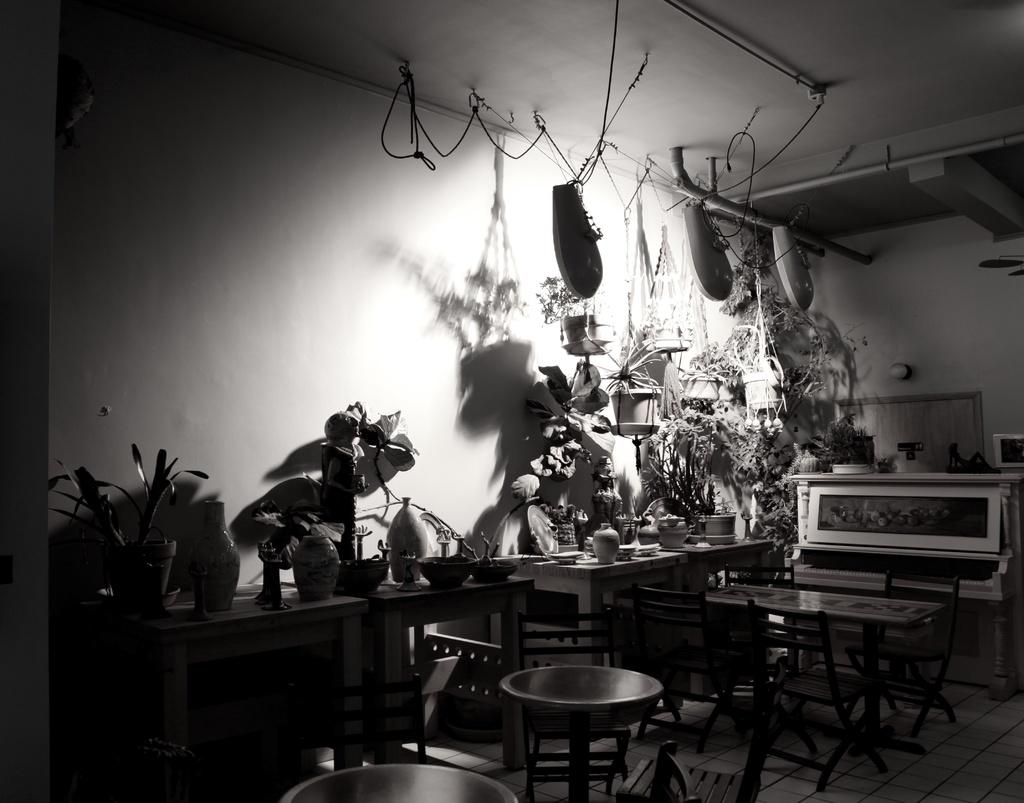What is the color scheme of the image? The image is black and white. What celestial bodies are depicted in the image? There are planets depicted in the image. What type of furniture is present in the image? There are tables and chairs in the image. What type of dishware is present in the image? There are bowls in the image. What other objects can be seen in the image? There are other objects in the image, but their specific details are not mentioned in the provided facts. What is visible at the top of the image? The ceiling is visible at the top of the image. How does the rock show respect to the planets in the image? There is no rock present in the image, and therefore no such interaction can be observed. 